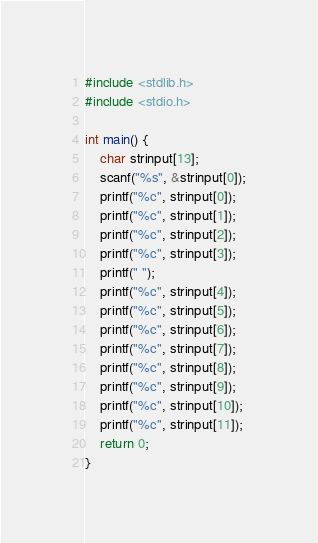<code> <loc_0><loc_0><loc_500><loc_500><_C_>#include <stdlib.h>
#include <stdio.h>

int main() {
    char strinput[13];
    scanf("%s", &strinput[0]);
    printf("%c", strinput[0]);
    printf("%c", strinput[1]);
    printf("%c", strinput[2]);
    printf("%c", strinput[3]);
    printf(" ");
    printf("%c", strinput[4]);
    printf("%c", strinput[5]);
    printf("%c", strinput[6]);
    printf("%c", strinput[7]);
    printf("%c", strinput[8]);
    printf("%c", strinput[9]);
    printf("%c", strinput[10]);
    printf("%c", strinput[11]);
    return 0;
}</code> 